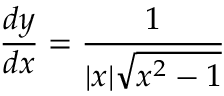<formula> <loc_0><loc_0><loc_500><loc_500>{ \frac { d y } { d x } } = { \frac { 1 } { | x | { \sqrt { x ^ { 2 } - 1 } } } }</formula> 